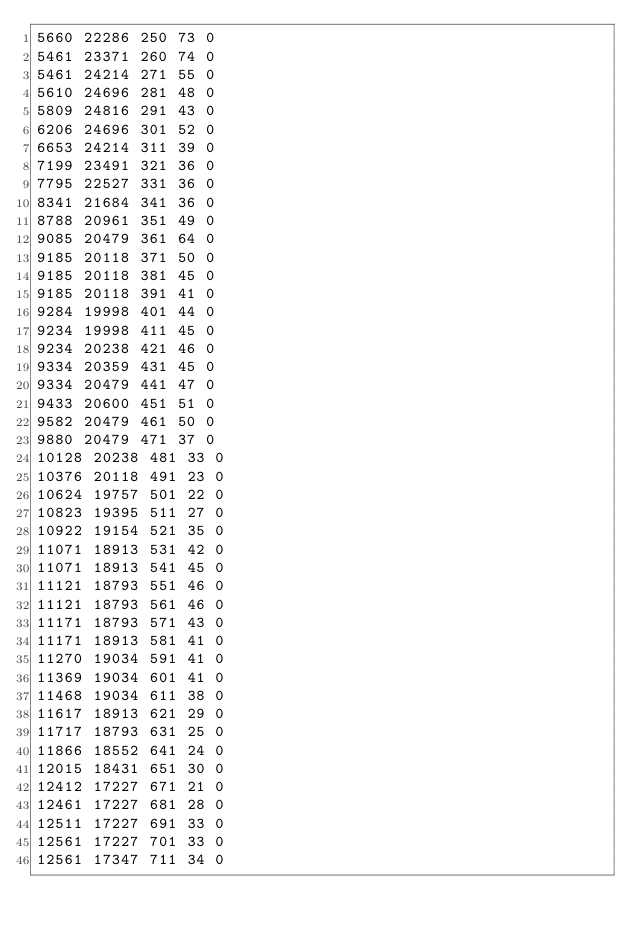Convert code to text. <code><loc_0><loc_0><loc_500><loc_500><_SML_>5660 22286 250 73 0
5461 23371 260 74 0
5461 24214 271 55 0
5610 24696 281 48 0
5809 24816 291 43 0
6206 24696 301 52 0
6653 24214 311 39 0
7199 23491 321 36 0
7795 22527 331 36 0
8341 21684 341 36 0
8788 20961 351 49 0
9085 20479 361 64 0
9185 20118 371 50 0
9185 20118 381 45 0
9185 20118 391 41 0
9284 19998 401 44 0
9234 19998 411 45 0
9234 20238 421 46 0
9334 20359 431 45 0
9334 20479 441 47 0
9433 20600 451 51 0
9582 20479 461 50 0
9880 20479 471 37 0
10128 20238 481 33 0
10376 20118 491 23 0
10624 19757 501 22 0
10823 19395 511 27 0
10922 19154 521 35 0
11071 18913 531 42 0
11071 18913 541 45 0
11121 18793 551 46 0
11121 18793 561 46 0
11171 18793 571 43 0
11171 18913 581 41 0
11270 19034 591 41 0
11369 19034 601 41 0
11468 19034 611 38 0
11617 18913 621 29 0
11717 18793 631 25 0
11866 18552 641 24 0
12015 18431 651 30 0
12412 17227 671 21 0
12461 17227 681 28 0
12511 17227 691 33 0
12561 17227 701 33 0
12561 17347 711 34 0</code> 